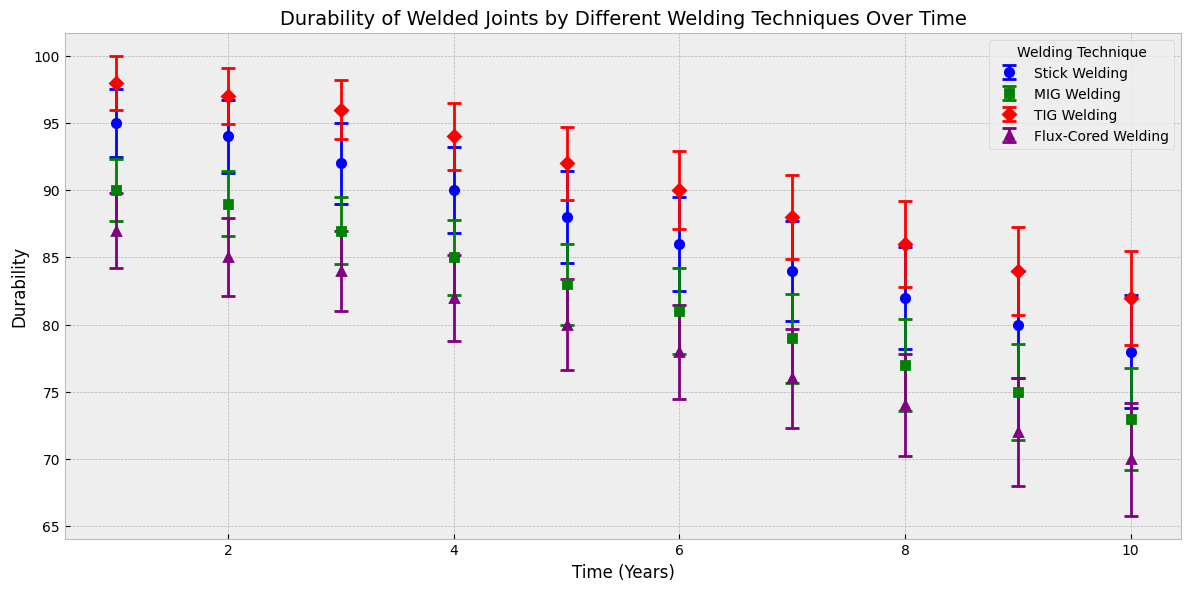What's the mean durability of TIG Welding at the beginning and end of the study? At the beginning (Timestamp 1), the mean durability for TIG Welding is 98. At the end (Timestamp 10), it is 82. This can be directly read from the plot's markers at these timestamps.
Answer: 98 and 82 Which welding technique shows the greatest decrease in mean durability over time? To find this, subtract the mean durability at Timestamp 10 from Timestamp 1 for each technique, and compare the differences: 
- Stick Welding: 95 - 78 = 17 
- MIG Welding: 90 - 73 = 17 
- TIG Welding: 98 - 82 = 16 
- Flux-Cored Welding: 87 - 70 = 17
The largest decrease is the same for Stick, MIG, and Flux-Cored Welding, at 17 units each.
Answer: Stick, MIG, and Flux-Cored Welding Which technique has the highest durability at Timestamp 5? At Timestamp 5, the plot shows that the highest mean durability is for TIG Welding, which has a mean durability value of 92.
Answer: TIG Welding Compare the durability trend of MIG Welding and Flux-Cored Welding. What can you infer? MIG Welding starts at 90 and decreases steadily to 73 over the 10 timestamps. Flux-Cored Welding starts at 87 and declines more sharply to 70. Both show a decreasing trend, but Flux-Cored Welding decreases at a slightly faster rate.
Answer: Both decrease, Flux-Cored faster Between Timestamp 3 and Timestamp 6, which technique shows the most consistent durability? Which is the least consistent? Consistency can be assessed by looking for minimal changes in mean durability over time. Stick Welding drops from 92 to 86 (6 units), MIG Welding from 87 to 81 (6 units), TIG Welding from 96 to 90 (6 units), and Flux-Cored from 84 to 78 (6 units). Since all drops are equal, none are truly more or less consistent than others between these timestamps.
Answer: All the same At which timestamps did TIG Welding have the highest and lowest standard error, and what were those errors? Reviewing the plot, the highest standard error for TIG Welding is at Timestamp 10, with a value of 3.5. The lowest standard error is at Timestamp 1, with a value of 2.0. These values are noted in the error bars' length along the y-axis.
Answer: Timestamp 1 (2.0) and Timestamp 10 (3.5) Which technique shows the smallest standard error on average? To determine the smallest standard error on average, compare the average length of the error bars for each technique. Calculating the average of the provided standard error values:
- Stick Welding: (2.5 + 2.7 + 3.0 + 3.2 + 3.4 + 3.5 + 3.7 + 3.8 + 4.0 + 4.2) / 10 = 3.4
- MIG Welding: (2.3 + 2.4 + 2.5 + 2.8 + 3.0 + 3.2 + 3.3 + 3.4 + 3.6 + 3.8) / 10 = 3.03
- TIG Welding: (2.0 + 2.1 + 2.2 + 2.5 + 2.7 + 2.9 + 3.1 + 3.2 + 3.3 + 3.5) / 10 = 2.75
- Flux-Cored Welding: (2.8 + 2.9 + 3.0 + 3.2 + 3.4 + 3.5 + 3.7 + 3.8 + 4.0 + 4.2) / 10 = 3.45
Thus, TIG Welding shows the smallest average standard error of 2.75.
Answer: TIG Welding Which technique's durability appears to decline the fastest over time? The fastest decline in durability over time can be judged by looking at the steepness of the trend lines. While all techniques show a decline, Flux-Cored Welding shows a visibly steeper decline from 87 to 70, especially compared to others with similar ranges.
Answer: Flux-Cored Welding 